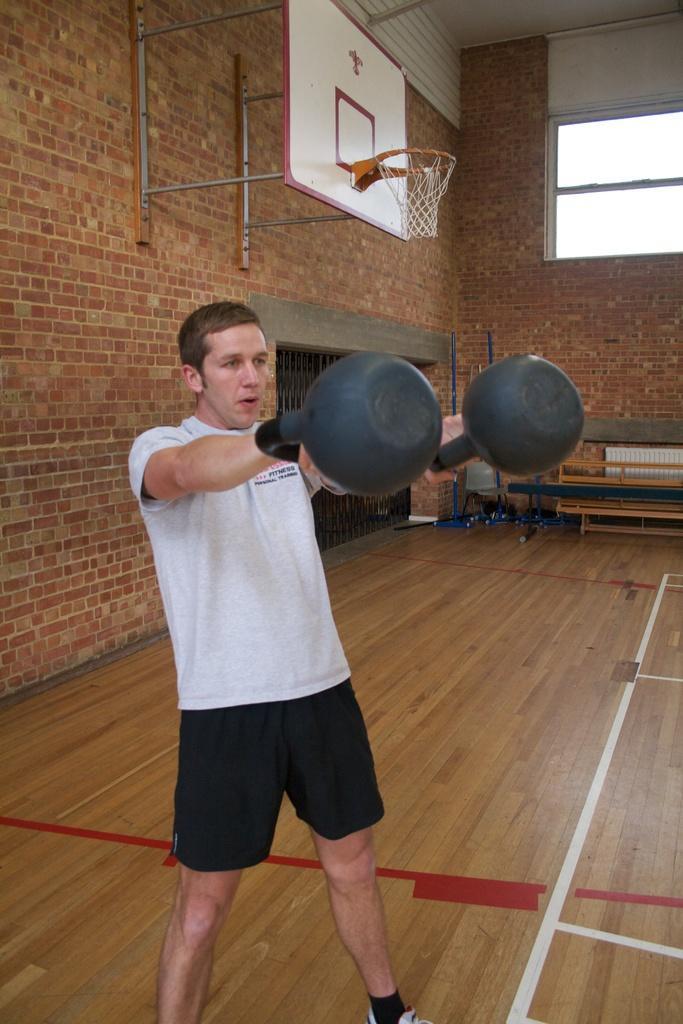Please provide a concise description of this image. In this image, we can see a person is standing and holding black objects. Background we can see brick walls, rods, basket, grille, glass window and few objects. At the bottom, we can see wooden floor. Through the glass window, we can see the sky. 